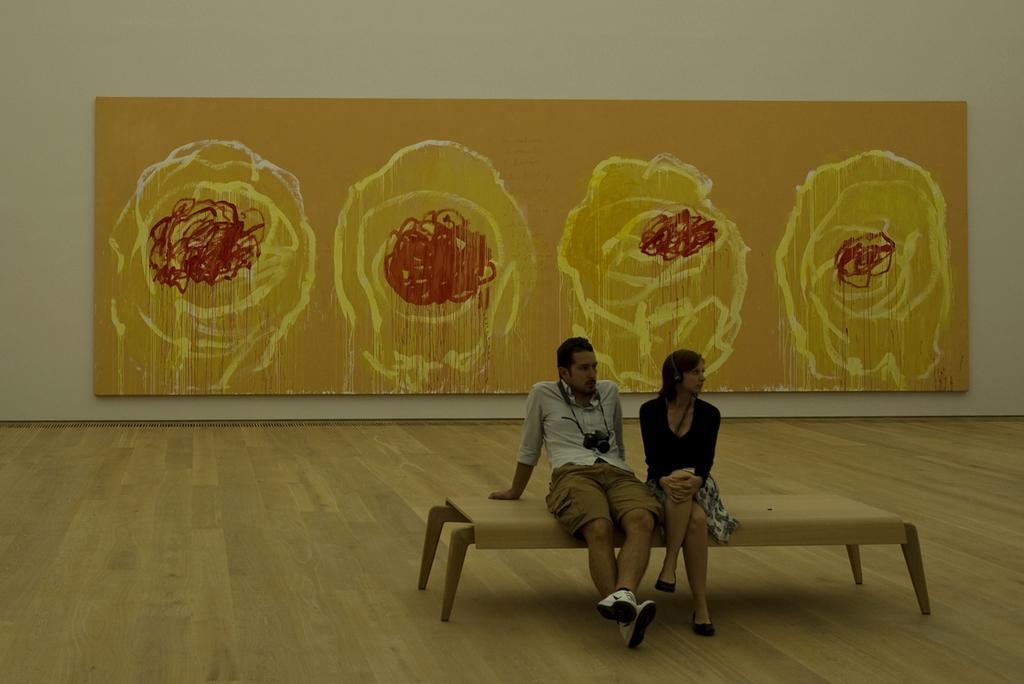Describe this image in one or two sentences. There is a man and a woman sitting on a bench. Man is wearing a camera. And the woman is wearing a headphones. In the back there's a wall. On the wall there is a painting. 